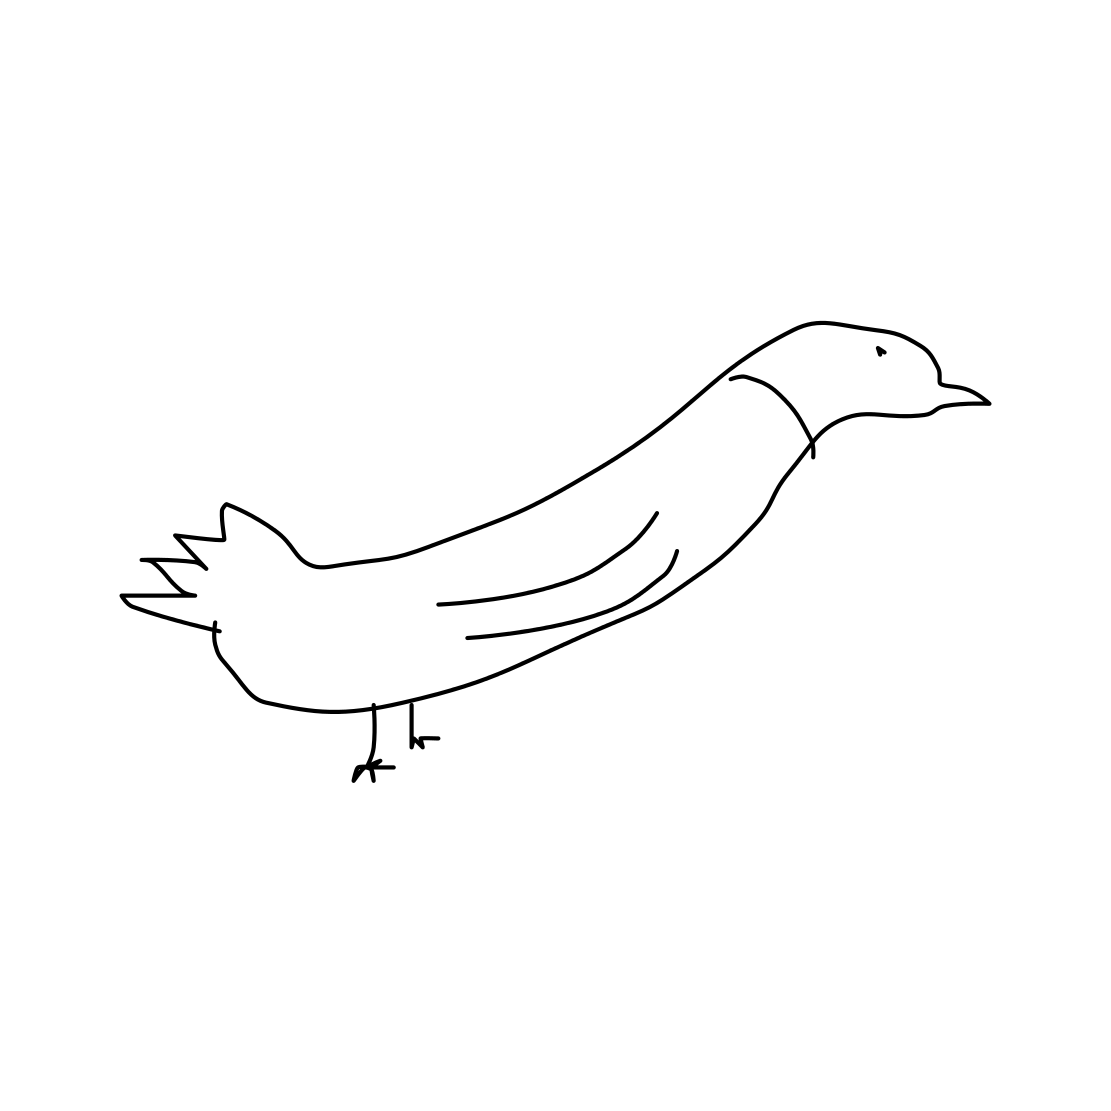What kind of bird does this drawing represent? This drawing resembles a stylized depiction of a bird, possibly a goose or a duck, given the shape of its beak and its overall silhouette. 